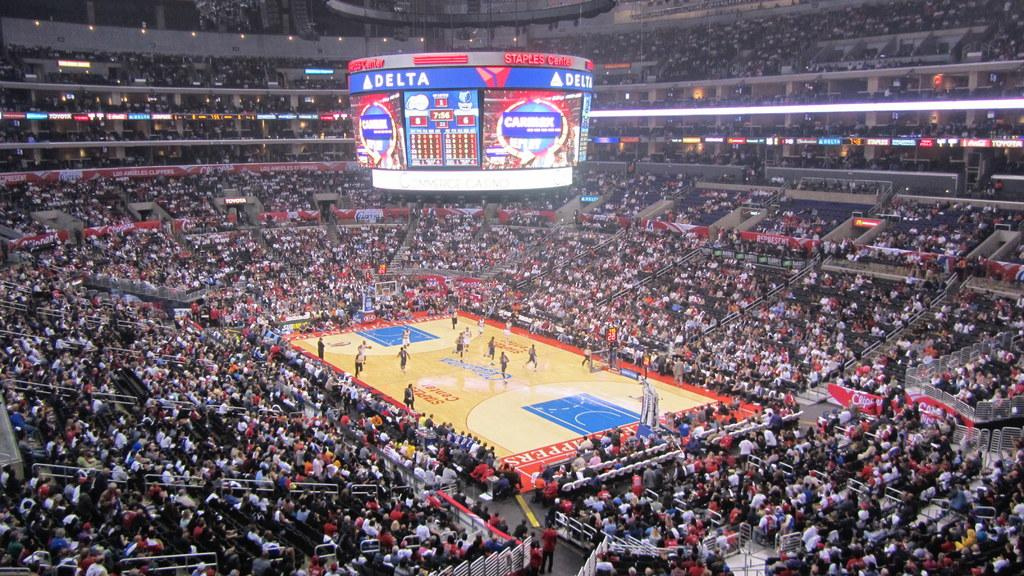<image>
Give a short and clear explanation of the subsequent image. Basketball court and arena full of people sponsored by Delta and Caremark. 